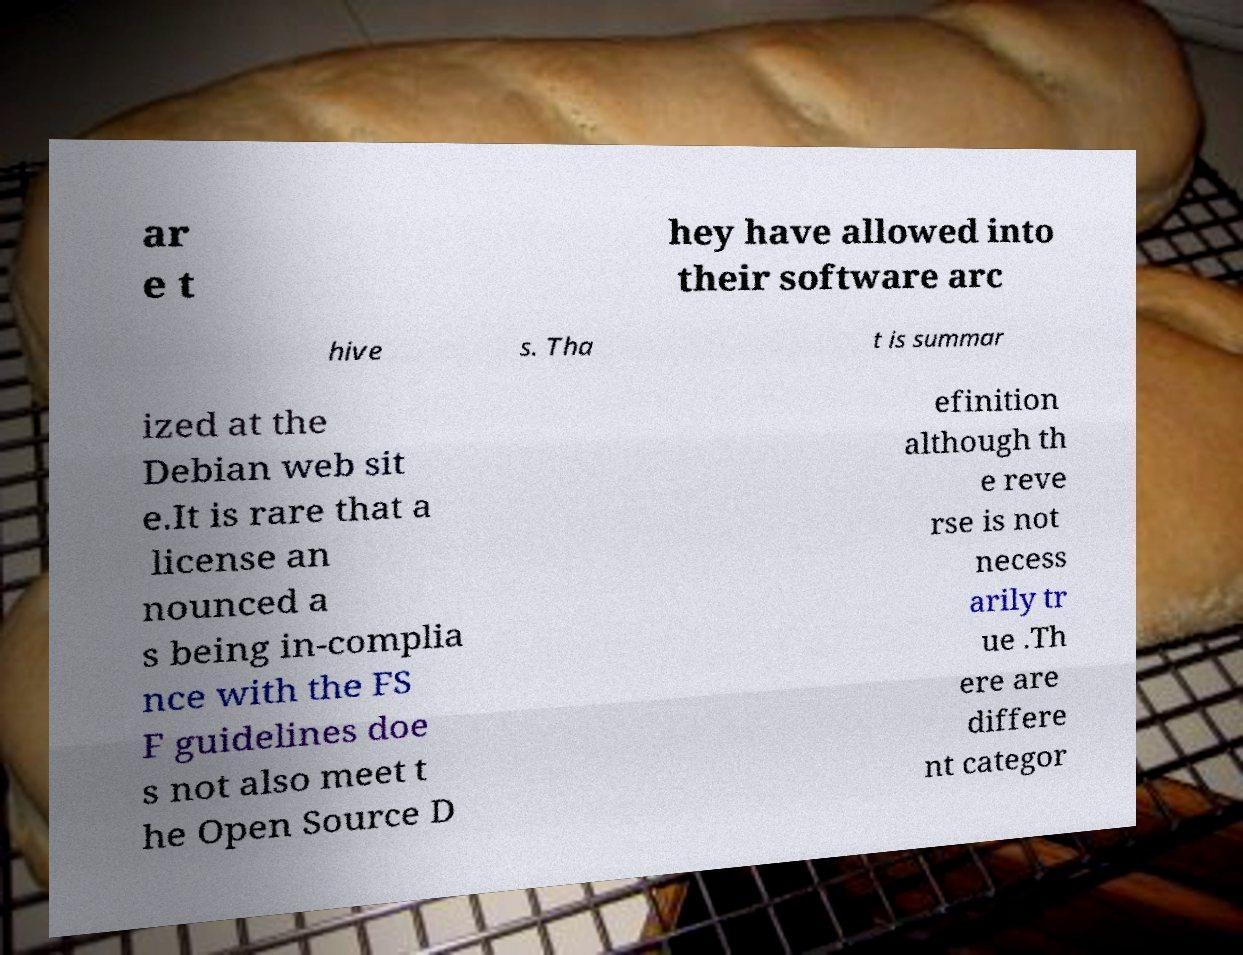What messages or text are displayed in this image? I need them in a readable, typed format. ar e t hey have allowed into their software arc hive s. Tha t is summar ized at the Debian web sit e.It is rare that a license an nounced a s being in-complia nce with the FS F guidelines doe s not also meet t he Open Source D efinition although th e reve rse is not necess arily tr ue .Th ere are differe nt categor 